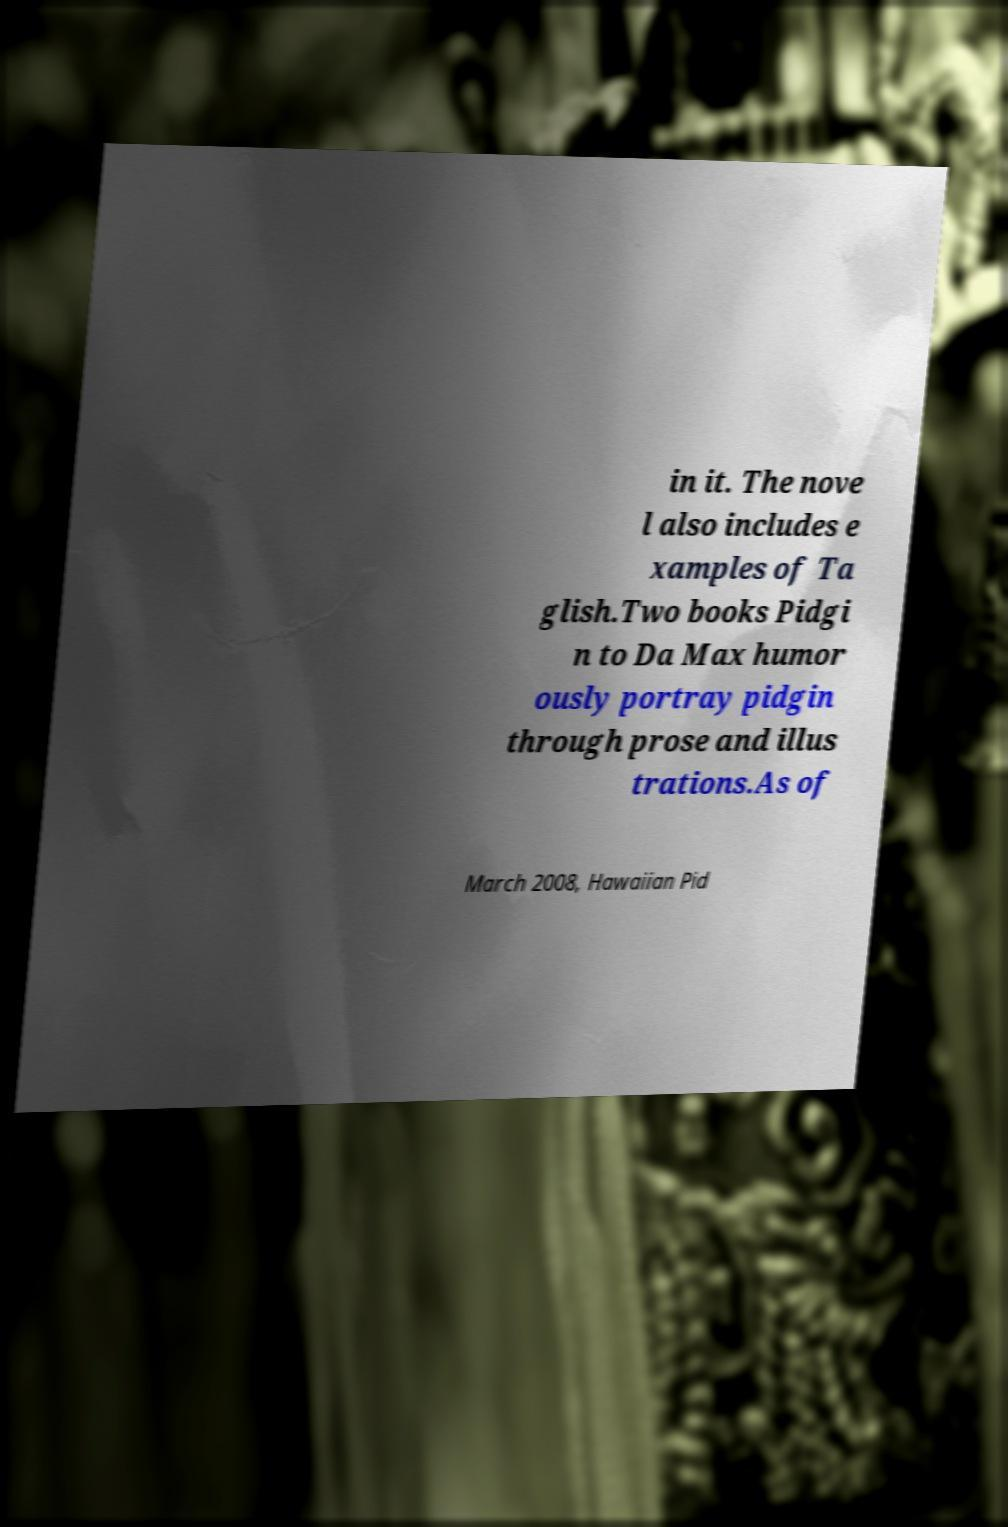What messages or text are displayed in this image? I need them in a readable, typed format. in it. The nove l also includes e xamples of Ta glish.Two books Pidgi n to Da Max humor ously portray pidgin through prose and illus trations.As of March 2008, Hawaiian Pid 